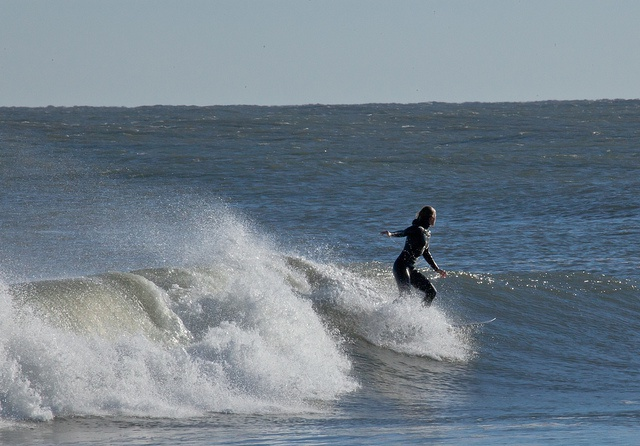Describe the objects in this image and their specific colors. I can see people in darkgray, black, and gray tones and surfboard in darkgray and gray tones in this image. 